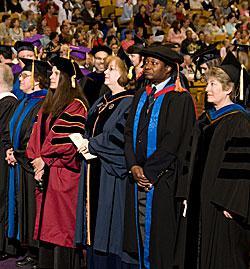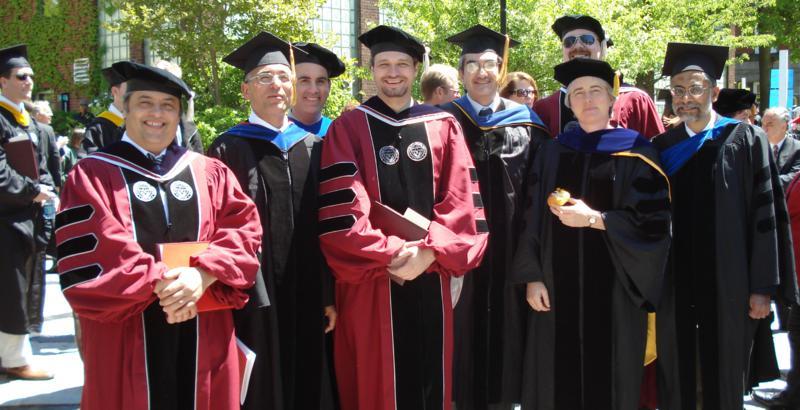The first image is the image on the left, the second image is the image on the right. Given the left and right images, does the statement "Graduates are standing on the sidewalk in the image on the left." hold true? Answer yes or no. No. The first image is the image on the left, the second image is the image on the right. Analyze the images presented: Is the assertion "Right image shows at least one person in a dark red graduation gown with black stripes on the sleeves." valid? Answer yes or no. Yes. 